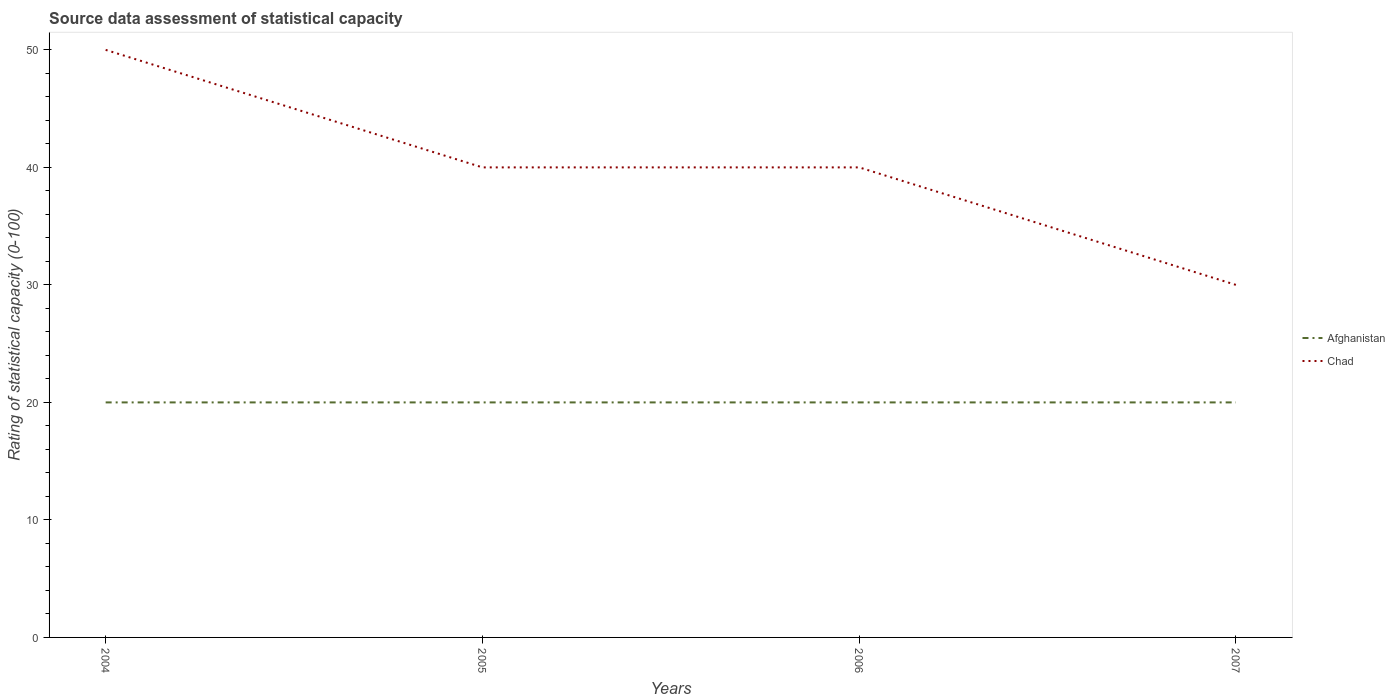How many different coloured lines are there?
Offer a very short reply. 2. Does the line corresponding to Chad intersect with the line corresponding to Afghanistan?
Offer a very short reply. No. Is the number of lines equal to the number of legend labels?
Provide a succinct answer. Yes. Across all years, what is the maximum rating of statistical capacity in Afghanistan?
Your answer should be compact. 20. In which year was the rating of statistical capacity in Chad maximum?
Your answer should be compact. 2007. What is the total rating of statistical capacity in Chad in the graph?
Ensure brevity in your answer.  10. What is the difference between the highest and the second highest rating of statistical capacity in Afghanistan?
Provide a succinct answer. 0. Is the rating of statistical capacity in Afghanistan strictly greater than the rating of statistical capacity in Chad over the years?
Give a very brief answer. Yes. How many years are there in the graph?
Give a very brief answer. 4. Are the values on the major ticks of Y-axis written in scientific E-notation?
Ensure brevity in your answer.  No. Does the graph contain grids?
Provide a succinct answer. No. Where does the legend appear in the graph?
Provide a short and direct response. Center right. How are the legend labels stacked?
Your answer should be compact. Vertical. What is the title of the graph?
Your answer should be very brief. Source data assessment of statistical capacity. Does "Sweden" appear as one of the legend labels in the graph?
Keep it short and to the point. No. What is the label or title of the X-axis?
Make the answer very short. Years. What is the label or title of the Y-axis?
Ensure brevity in your answer.  Rating of statistical capacity (0-100). What is the Rating of statistical capacity (0-100) of Afghanistan in 2004?
Your response must be concise. 20. What is the Rating of statistical capacity (0-100) of Afghanistan in 2005?
Make the answer very short. 20. What is the Rating of statistical capacity (0-100) of Afghanistan in 2007?
Provide a short and direct response. 20. Across all years, what is the maximum Rating of statistical capacity (0-100) in Chad?
Ensure brevity in your answer.  50. What is the total Rating of statistical capacity (0-100) of Afghanistan in the graph?
Your answer should be very brief. 80. What is the total Rating of statistical capacity (0-100) in Chad in the graph?
Your answer should be very brief. 160. What is the difference between the Rating of statistical capacity (0-100) of Afghanistan in 2004 and that in 2005?
Provide a short and direct response. 0. What is the difference between the Rating of statistical capacity (0-100) of Chad in 2004 and that in 2005?
Make the answer very short. 10. What is the difference between the Rating of statistical capacity (0-100) of Afghanistan in 2004 and that in 2006?
Offer a terse response. 0. What is the difference between the Rating of statistical capacity (0-100) in Chad in 2004 and that in 2006?
Your response must be concise. 10. What is the difference between the Rating of statistical capacity (0-100) of Chad in 2005 and that in 2006?
Provide a succinct answer. 0. What is the difference between the Rating of statistical capacity (0-100) in Chad in 2005 and that in 2007?
Make the answer very short. 10. What is the difference between the Rating of statistical capacity (0-100) of Afghanistan in 2006 and that in 2007?
Ensure brevity in your answer.  0. What is the difference between the Rating of statistical capacity (0-100) of Chad in 2006 and that in 2007?
Provide a succinct answer. 10. What is the difference between the Rating of statistical capacity (0-100) of Afghanistan in 2004 and the Rating of statistical capacity (0-100) of Chad in 2006?
Give a very brief answer. -20. What is the difference between the Rating of statistical capacity (0-100) of Afghanistan in 2004 and the Rating of statistical capacity (0-100) of Chad in 2007?
Your response must be concise. -10. What is the difference between the Rating of statistical capacity (0-100) of Afghanistan in 2006 and the Rating of statistical capacity (0-100) of Chad in 2007?
Your answer should be compact. -10. In the year 2004, what is the difference between the Rating of statistical capacity (0-100) in Afghanistan and Rating of statistical capacity (0-100) in Chad?
Offer a terse response. -30. In the year 2005, what is the difference between the Rating of statistical capacity (0-100) in Afghanistan and Rating of statistical capacity (0-100) in Chad?
Keep it short and to the point. -20. What is the ratio of the Rating of statistical capacity (0-100) in Afghanistan in 2004 to that in 2005?
Offer a very short reply. 1. What is the ratio of the Rating of statistical capacity (0-100) of Chad in 2004 to that in 2005?
Your answer should be very brief. 1.25. What is the ratio of the Rating of statistical capacity (0-100) of Afghanistan in 2004 to that in 2006?
Make the answer very short. 1. What is the ratio of the Rating of statistical capacity (0-100) of Chad in 2004 to that in 2007?
Give a very brief answer. 1.67. What is the ratio of the Rating of statistical capacity (0-100) in Afghanistan in 2006 to that in 2007?
Provide a succinct answer. 1. What is the difference between the highest and the second highest Rating of statistical capacity (0-100) in Chad?
Ensure brevity in your answer.  10. What is the difference between the highest and the lowest Rating of statistical capacity (0-100) in Afghanistan?
Make the answer very short. 0. 